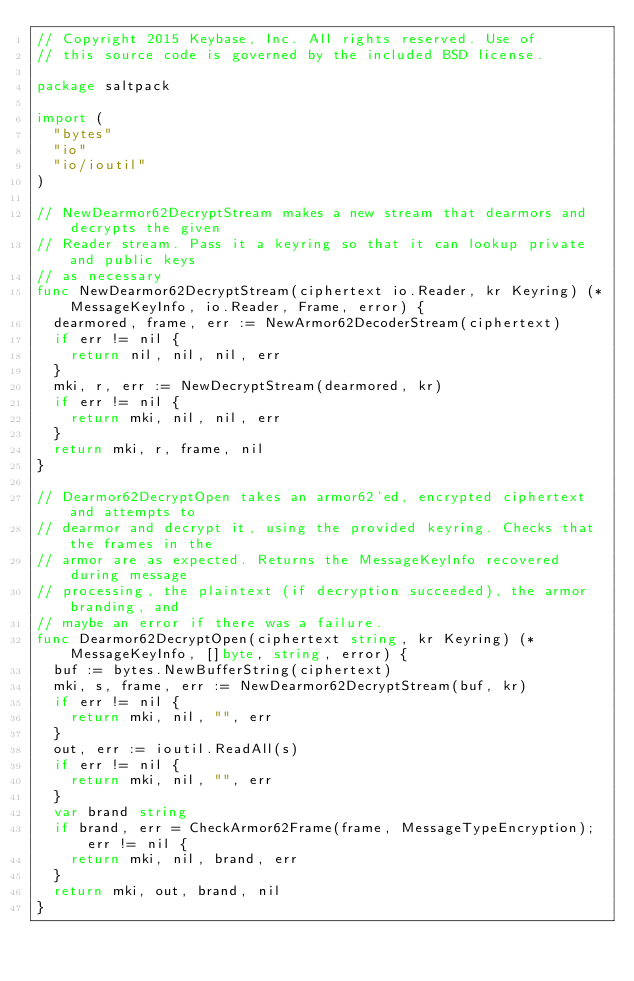Convert code to text. <code><loc_0><loc_0><loc_500><loc_500><_Go_>// Copyright 2015 Keybase, Inc. All rights reserved. Use of
// this source code is governed by the included BSD license.

package saltpack

import (
	"bytes"
	"io"
	"io/ioutil"
)

// NewDearmor62DecryptStream makes a new stream that dearmors and decrypts the given
// Reader stream. Pass it a keyring so that it can lookup private and public keys
// as necessary
func NewDearmor62DecryptStream(ciphertext io.Reader, kr Keyring) (*MessageKeyInfo, io.Reader, Frame, error) {
	dearmored, frame, err := NewArmor62DecoderStream(ciphertext)
	if err != nil {
		return nil, nil, nil, err
	}
	mki, r, err := NewDecryptStream(dearmored, kr)
	if err != nil {
		return mki, nil, nil, err
	}
	return mki, r, frame, nil
}

// Dearmor62DecryptOpen takes an armor62'ed, encrypted ciphertext and attempts to
// dearmor and decrypt it, using the provided keyring. Checks that the frames in the
// armor are as expected. Returns the MessageKeyInfo recovered during message
// processing, the plaintext (if decryption succeeded), the armor branding, and
// maybe an error if there was a failure.
func Dearmor62DecryptOpen(ciphertext string, kr Keyring) (*MessageKeyInfo, []byte, string, error) {
	buf := bytes.NewBufferString(ciphertext)
	mki, s, frame, err := NewDearmor62DecryptStream(buf, kr)
	if err != nil {
		return mki, nil, "", err
	}
	out, err := ioutil.ReadAll(s)
	if err != nil {
		return mki, nil, "", err
	}
	var brand string
	if brand, err = CheckArmor62Frame(frame, MessageTypeEncryption); err != nil {
		return mki, nil, brand, err
	}
	return mki, out, brand, nil
}
</code> 